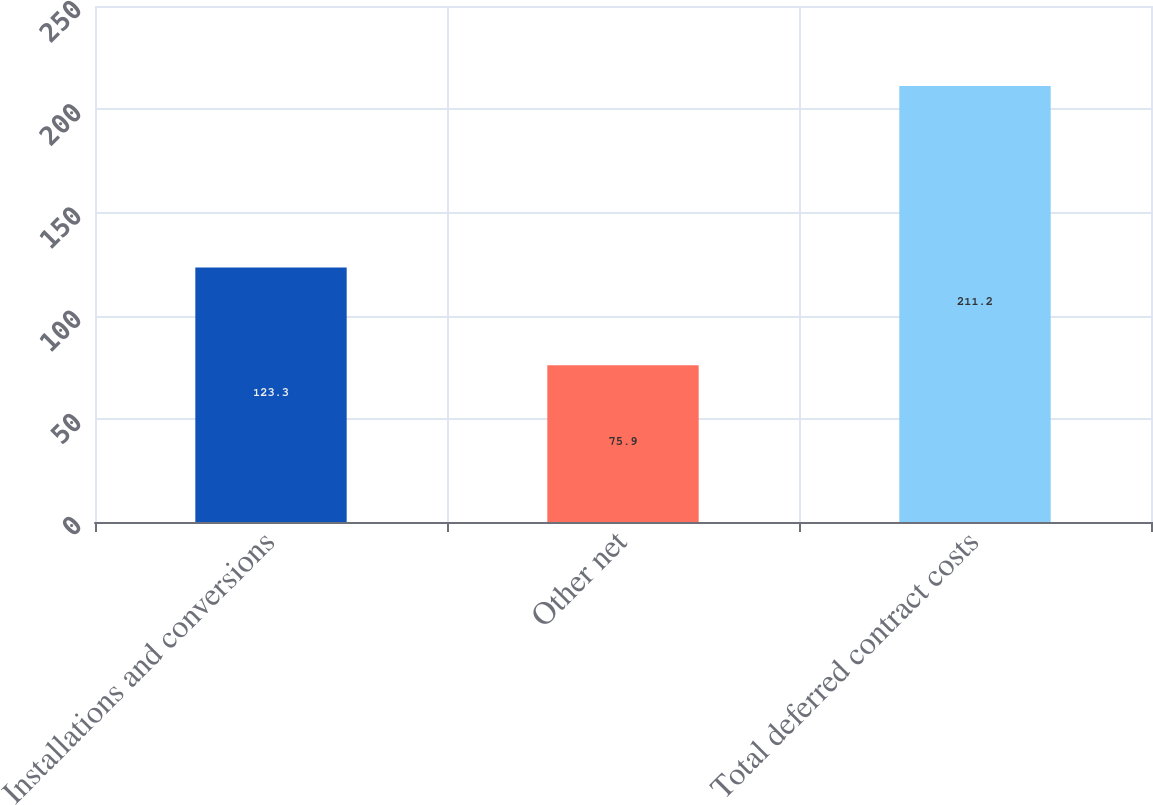Convert chart. <chart><loc_0><loc_0><loc_500><loc_500><bar_chart><fcel>Installations and conversions<fcel>Other net<fcel>Total deferred contract costs<nl><fcel>123.3<fcel>75.9<fcel>211.2<nl></chart> 